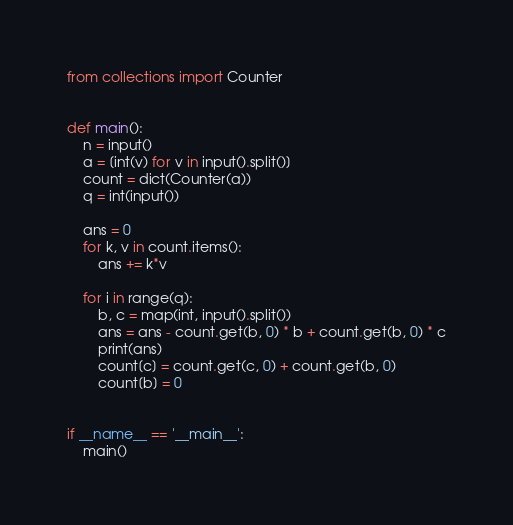<code> <loc_0><loc_0><loc_500><loc_500><_Python_>from collections import Counter


def main():
    n = input()
    a = [int(v) for v in input().split()]
    count = dict(Counter(a))
    q = int(input())

    ans = 0
    for k, v in count.items():
        ans += k*v

    for i in range(q):
        b, c = map(int, input().split())
        ans = ans - count.get(b, 0) * b + count.get(b, 0) * c
        print(ans)
        count[c] = count.get(c, 0) + count.get(b, 0)
        count[b] = 0


if __name__ == '__main__':
    main()
</code> 